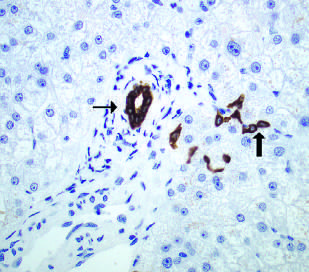where are liver stem cells (oval cells) located?
Answer the question using a single word or phrase. In the canals of hering 